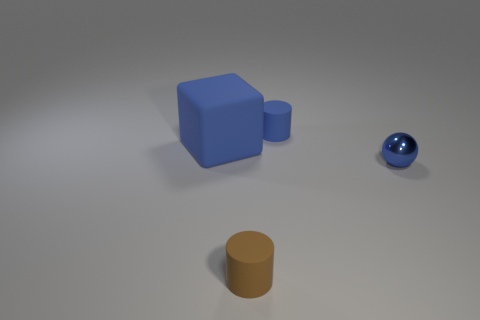Add 3 gray rubber cylinders. How many objects exist? 7 Subtract all blocks. How many objects are left? 3 Subtract all green spheres. Subtract all purple cubes. How many spheres are left? 1 Subtract all small blue cylinders. Subtract all cylinders. How many objects are left? 1 Add 4 tiny things. How many tiny things are left? 7 Add 3 small green shiny cubes. How many small green shiny cubes exist? 3 Subtract 0 gray spheres. How many objects are left? 4 